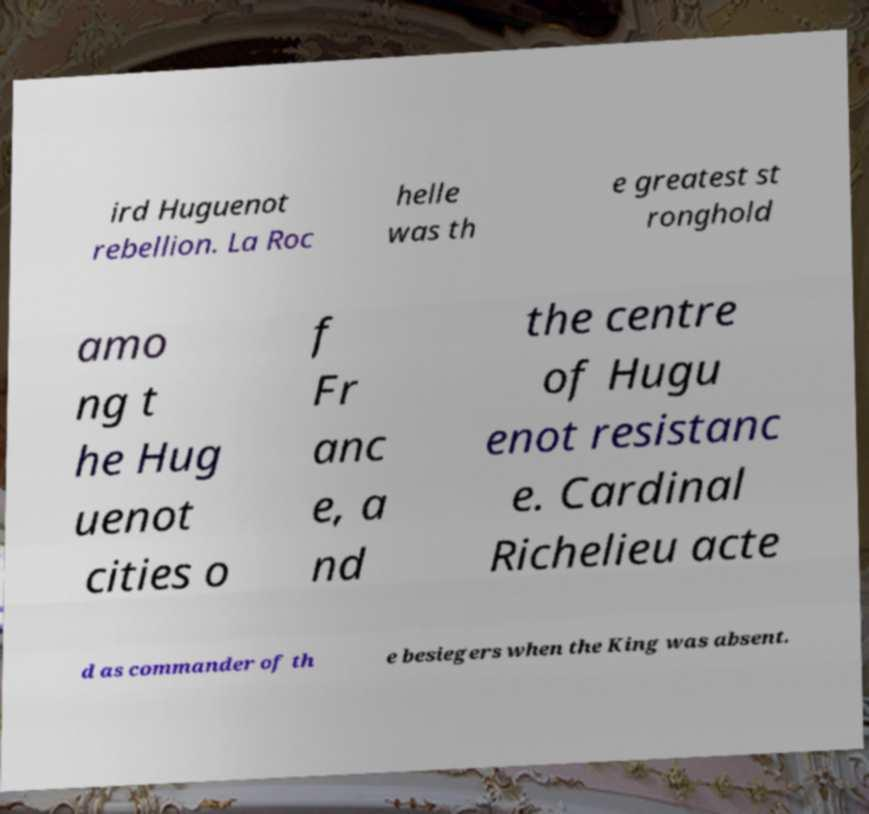I need the written content from this picture converted into text. Can you do that? ird Huguenot rebellion. La Roc helle was th e greatest st ronghold amo ng t he Hug uenot cities o f Fr anc e, a nd the centre of Hugu enot resistanc e. Cardinal Richelieu acte d as commander of th e besiegers when the King was absent. 